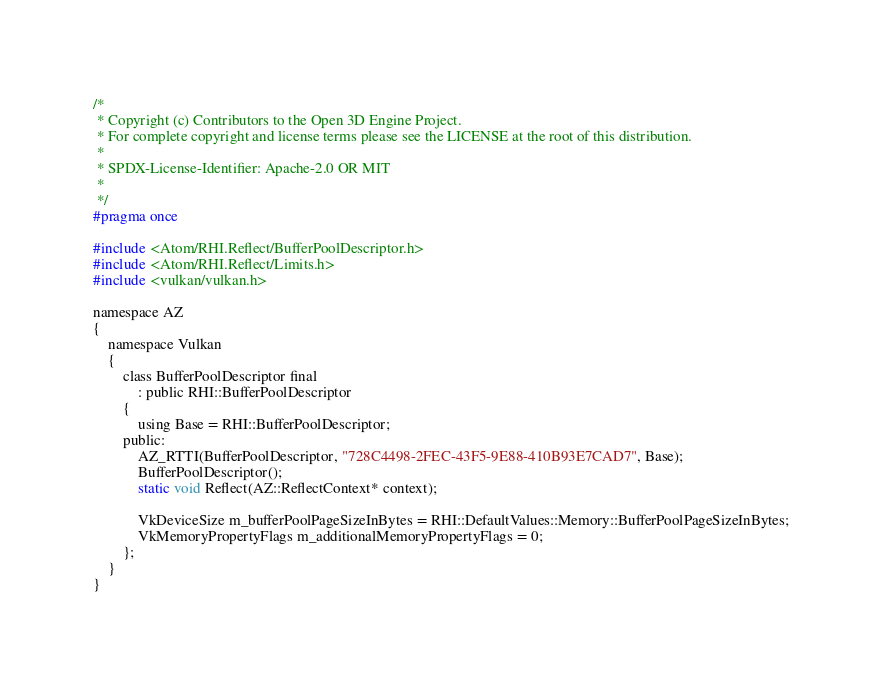<code> <loc_0><loc_0><loc_500><loc_500><_C_>/*
 * Copyright (c) Contributors to the Open 3D Engine Project.
 * For complete copyright and license terms please see the LICENSE at the root of this distribution.
 *
 * SPDX-License-Identifier: Apache-2.0 OR MIT
 *
 */
#pragma once

#include <Atom/RHI.Reflect/BufferPoolDescriptor.h>
#include <Atom/RHI.Reflect/Limits.h>
#include <vulkan/vulkan.h>

namespace AZ
{
    namespace Vulkan
    {
        class BufferPoolDescriptor final
            : public RHI::BufferPoolDescriptor
        {
            using Base = RHI::BufferPoolDescriptor;
        public:
            AZ_RTTI(BufferPoolDescriptor, "728C4498-2FEC-43F5-9E88-410B93E7CAD7", Base);
            BufferPoolDescriptor();
            static void Reflect(AZ::ReflectContext* context);

            VkDeviceSize m_bufferPoolPageSizeInBytes = RHI::DefaultValues::Memory::BufferPoolPageSizeInBytes;
            VkMemoryPropertyFlags m_additionalMemoryPropertyFlags = 0;
        };
    }
}
</code> 